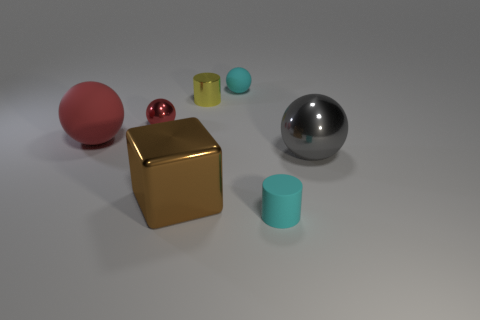Is the big rubber ball the same color as the tiny metallic sphere?
Keep it short and to the point. Yes. What is the size of the shiny ball right of the brown block?
Offer a terse response. Large. There is a thing that is the same color as the tiny metallic ball; what shape is it?
Keep it short and to the point. Sphere. Are the big brown object and the tiny cyan thing that is in front of the gray ball made of the same material?
Offer a very short reply. No. There is a cyan thing that is on the left side of the small cyan object in front of the large cube; what number of red objects are right of it?
Your answer should be very brief. 0. What number of blue things are either large shiny spheres or big rubber cylinders?
Your answer should be compact. 0. The big shiny object that is to the right of the yellow shiny thing has what shape?
Your answer should be very brief. Sphere. There is a matte object that is the same size as the brown shiny thing; what color is it?
Provide a short and direct response. Red. Is the shape of the yellow metallic thing the same as the matte thing that is on the left side of the yellow cylinder?
Keep it short and to the point. No. What material is the tiny cyan object that is to the left of the small object that is to the right of the small sphere to the right of the red metallic ball?
Make the answer very short. Rubber. 